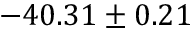Convert formula to latex. <formula><loc_0><loc_0><loc_500><loc_500>- 4 0 . 3 1 \pm 0 . 2 1</formula> 